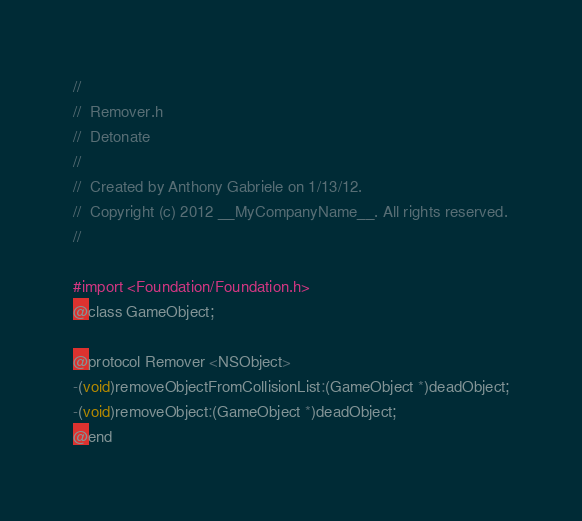<code> <loc_0><loc_0><loc_500><loc_500><_C_>//
//  Remover.h
//  Detonate
//
//  Created by Anthony Gabriele on 1/13/12.
//  Copyright (c) 2012 __MyCompanyName__. All rights reserved.
//

#import <Foundation/Foundation.h>
@class GameObject;

@protocol Remover <NSObject>
-(void)removeObjectFromCollisionList:(GameObject *)deadObject;
-(void)removeObject:(GameObject *)deadObject;
@end
</code> 